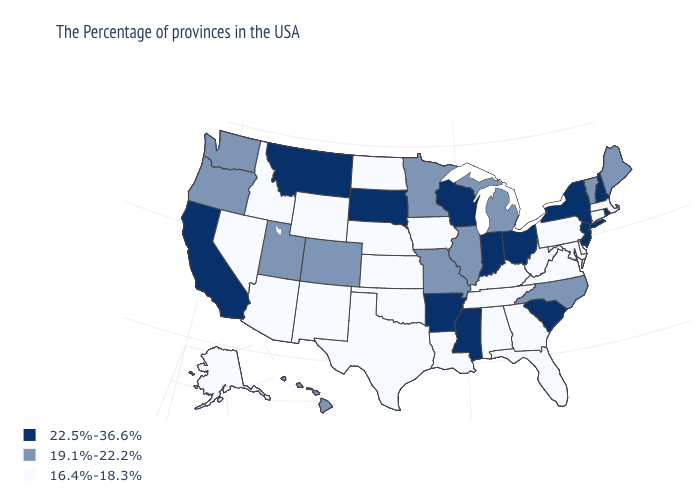Among the states that border New York , does New Jersey have the highest value?
Answer briefly. Yes. Is the legend a continuous bar?
Concise answer only. No. How many symbols are there in the legend?
Give a very brief answer. 3. Name the states that have a value in the range 19.1%-22.2%?
Answer briefly. Maine, Vermont, North Carolina, Michigan, Illinois, Missouri, Minnesota, Colorado, Utah, Washington, Oregon, Hawaii. Which states have the highest value in the USA?
Keep it brief. Rhode Island, New Hampshire, New York, New Jersey, South Carolina, Ohio, Indiana, Wisconsin, Mississippi, Arkansas, South Dakota, Montana, California. What is the value of New Mexico?
Quick response, please. 16.4%-18.3%. Among the states that border Oregon , does California have the highest value?
Concise answer only. Yes. Does New Mexico have the highest value in the USA?
Be succinct. No. What is the value of Alaska?
Be succinct. 16.4%-18.3%. Which states have the highest value in the USA?
Concise answer only. Rhode Island, New Hampshire, New York, New Jersey, South Carolina, Ohio, Indiana, Wisconsin, Mississippi, Arkansas, South Dakota, Montana, California. Name the states that have a value in the range 16.4%-18.3%?
Give a very brief answer. Massachusetts, Connecticut, Delaware, Maryland, Pennsylvania, Virginia, West Virginia, Florida, Georgia, Kentucky, Alabama, Tennessee, Louisiana, Iowa, Kansas, Nebraska, Oklahoma, Texas, North Dakota, Wyoming, New Mexico, Arizona, Idaho, Nevada, Alaska. What is the lowest value in states that border Missouri?
Answer briefly. 16.4%-18.3%. Name the states that have a value in the range 22.5%-36.6%?
Answer briefly. Rhode Island, New Hampshire, New York, New Jersey, South Carolina, Ohio, Indiana, Wisconsin, Mississippi, Arkansas, South Dakota, Montana, California. Does Massachusetts have the same value as Maine?
Short answer required. No. 